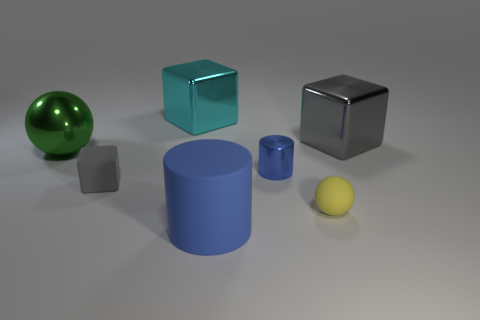There is a large shiny thing that is behind the big gray block; is its shape the same as the small rubber object that is on the left side of the blue matte thing?
Keep it short and to the point. Yes. How big is the blue cylinder that is left of the tiny cylinder?
Offer a very short reply. Large. There is a metal cube on the right side of the cylinder behind the blue rubber cylinder; what size is it?
Offer a terse response. Large. Are there more tiny cylinders than big yellow shiny spheres?
Your response must be concise. Yes. Are there more cylinders behind the small sphere than small spheres behind the tiny blue shiny thing?
Provide a short and direct response. Yes. What size is the metallic object that is behind the tiny blue metal cylinder and on the right side of the big blue thing?
Your answer should be compact. Large. How many rubber spheres are the same size as the green metal thing?
Offer a terse response. 0. What is the material of the other thing that is the same color as the small metal thing?
Ensure brevity in your answer.  Rubber. There is a matte thing to the right of the small blue cylinder; is it the same shape as the green object?
Give a very brief answer. Yes. Is the number of yellow spheres that are in front of the small rubber ball less than the number of large gray rubber things?
Make the answer very short. No. 